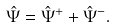Convert formula to latex. <formula><loc_0><loc_0><loc_500><loc_500>\hat { \Psi } = \hat { \Psi } ^ { + } + \hat { \Psi } ^ { - } .</formula> 